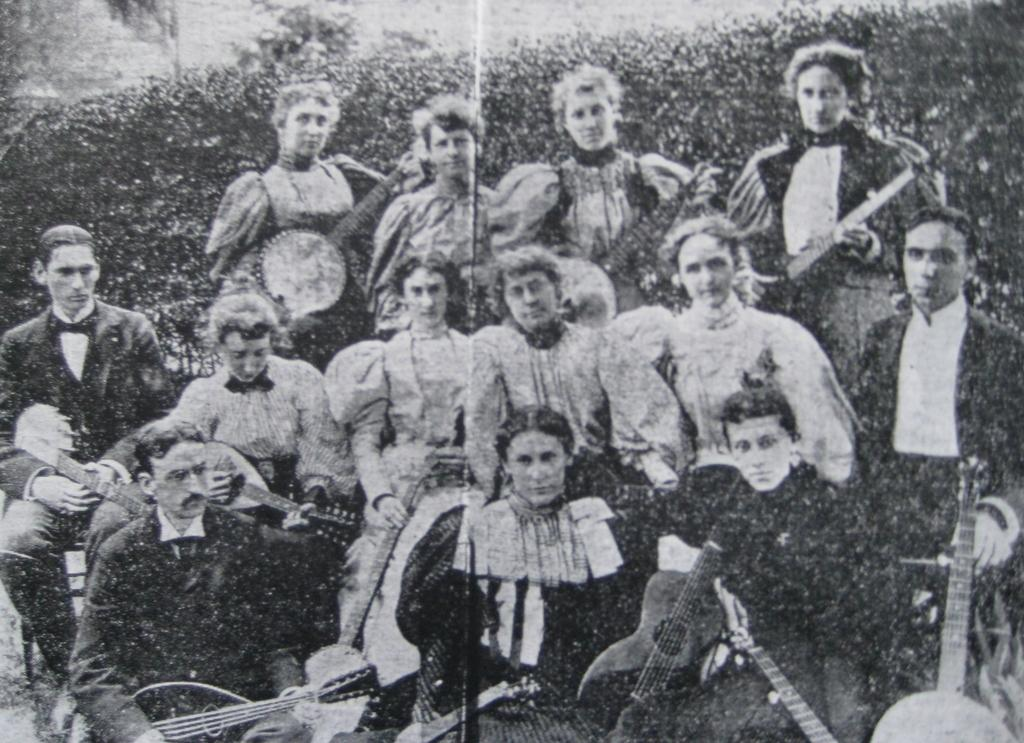How many people are in the image? There are multiple people in the image. What are the people doing in the image? Most of the people are holding musical instruments. What is the color scheme of the image? The image is black and white in color. What type of advice can be seen written on the vessel in the image? There is no vessel or advice present in the image; it features multiple people holding musical instruments in a black and white setting. 